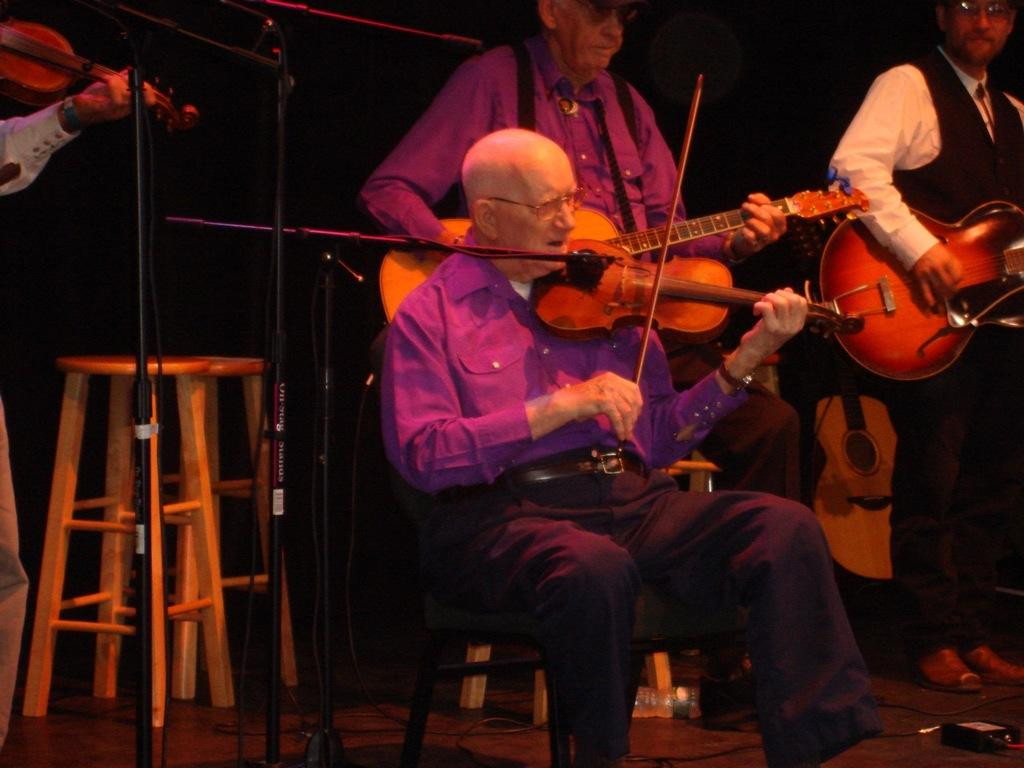What is the man in the image doing? The man is sitting on a chair and playing a violin in the image. Can you describe the people in the background of the image? The people in the background are standing and playing a guitar. What objects can be seen in the image besides the musical instruments? There is a table, a microphone, and a bottle in the image. What type of paste is being used to clean the dirt off the floor in the image? There is no paste or dirt visible in the image; it features a man playing the violin, people playing the guitar, and various objects. 